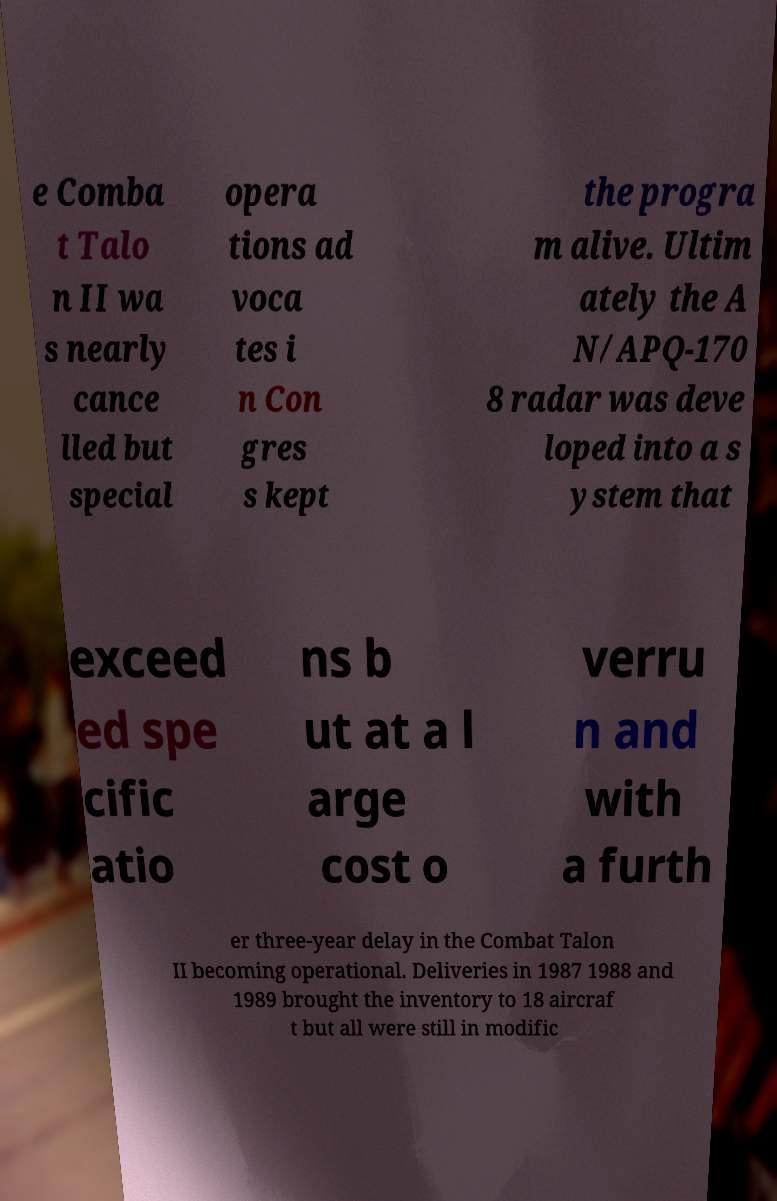Please identify and transcribe the text found in this image. e Comba t Talo n II wa s nearly cance lled but special opera tions ad voca tes i n Con gres s kept the progra m alive. Ultim ately the A N/APQ-170 8 radar was deve loped into a s ystem that exceed ed spe cific atio ns b ut at a l arge cost o verru n and with a furth er three-year delay in the Combat Talon II becoming operational. Deliveries in 1987 1988 and 1989 brought the inventory to 18 aircraf t but all were still in modific 